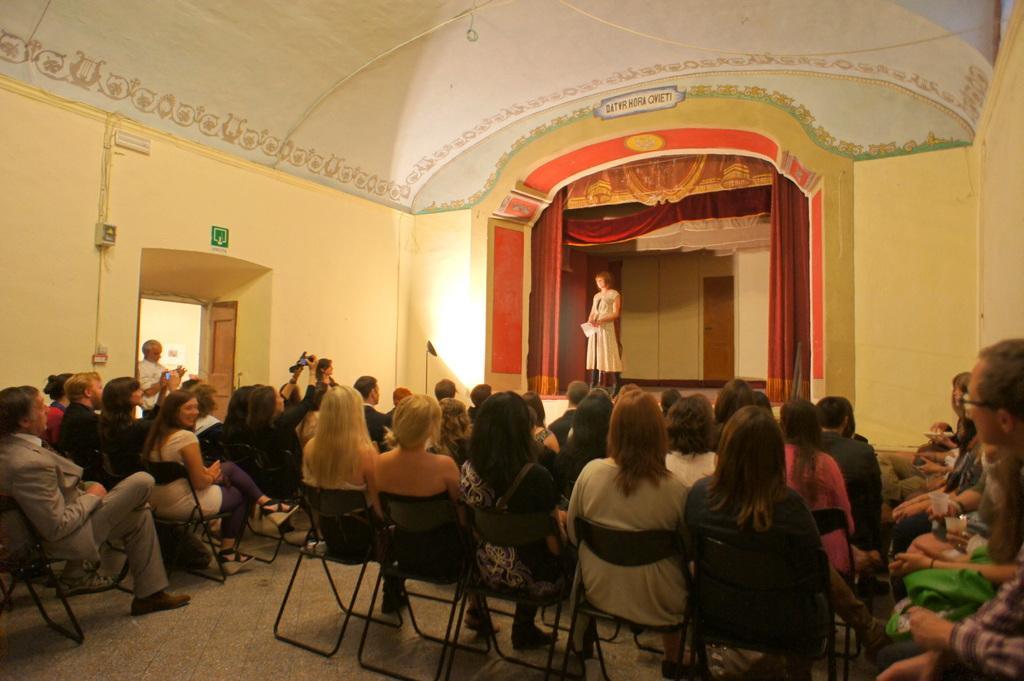In one or two sentences, can you explain what this image depicts? There are many persons sitting on chairs. On the stage a lady is standing. There is a curtain on the stage. On the left side there is an entrance. There are pipes on the walls. 